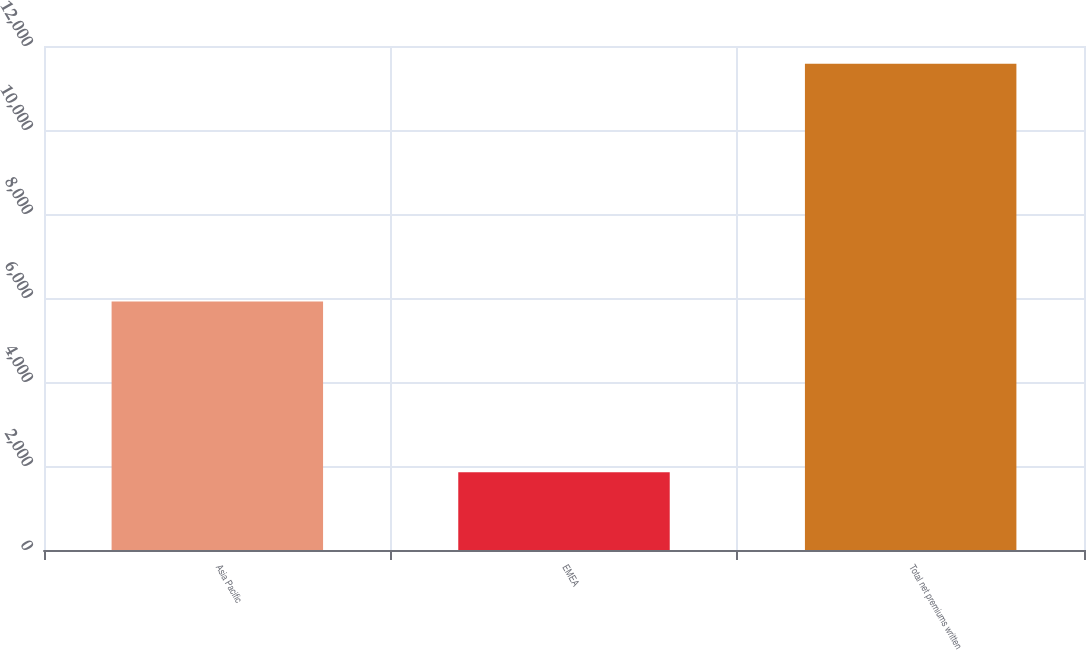<chart> <loc_0><loc_0><loc_500><loc_500><bar_chart><fcel>Asia Pacific<fcel>EMEA<fcel>Total net premiums written<nl><fcel>5916<fcel>1854<fcel>11580<nl></chart> 